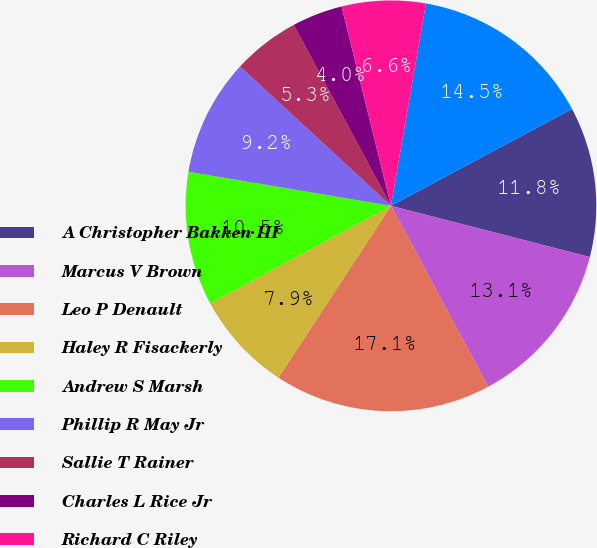<chart> <loc_0><loc_0><loc_500><loc_500><pie_chart><fcel>A Christopher Bakken III<fcel>Marcus V Brown<fcel>Leo P Denault<fcel>Haley R Fisackerly<fcel>Andrew S Marsh<fcel>Phillip R May Jr<fcel>Sallie T Rainer<fcel>Charles L Rice Jr<fcel>Richard C Riley<fcel>Roderick K West<nl><fcel>11.83%<fcel>13.14%<fcel>17.07%<fcel>7.9%<fcel>10.52%<fcel>9.21%<fcel>5.29%<fcel>3.98%<fcel>6.59%<fcel>14.45%<nl></chart> 